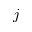<formula> <loc_0><loc_0><loc_500><loc_500>j</formula> 